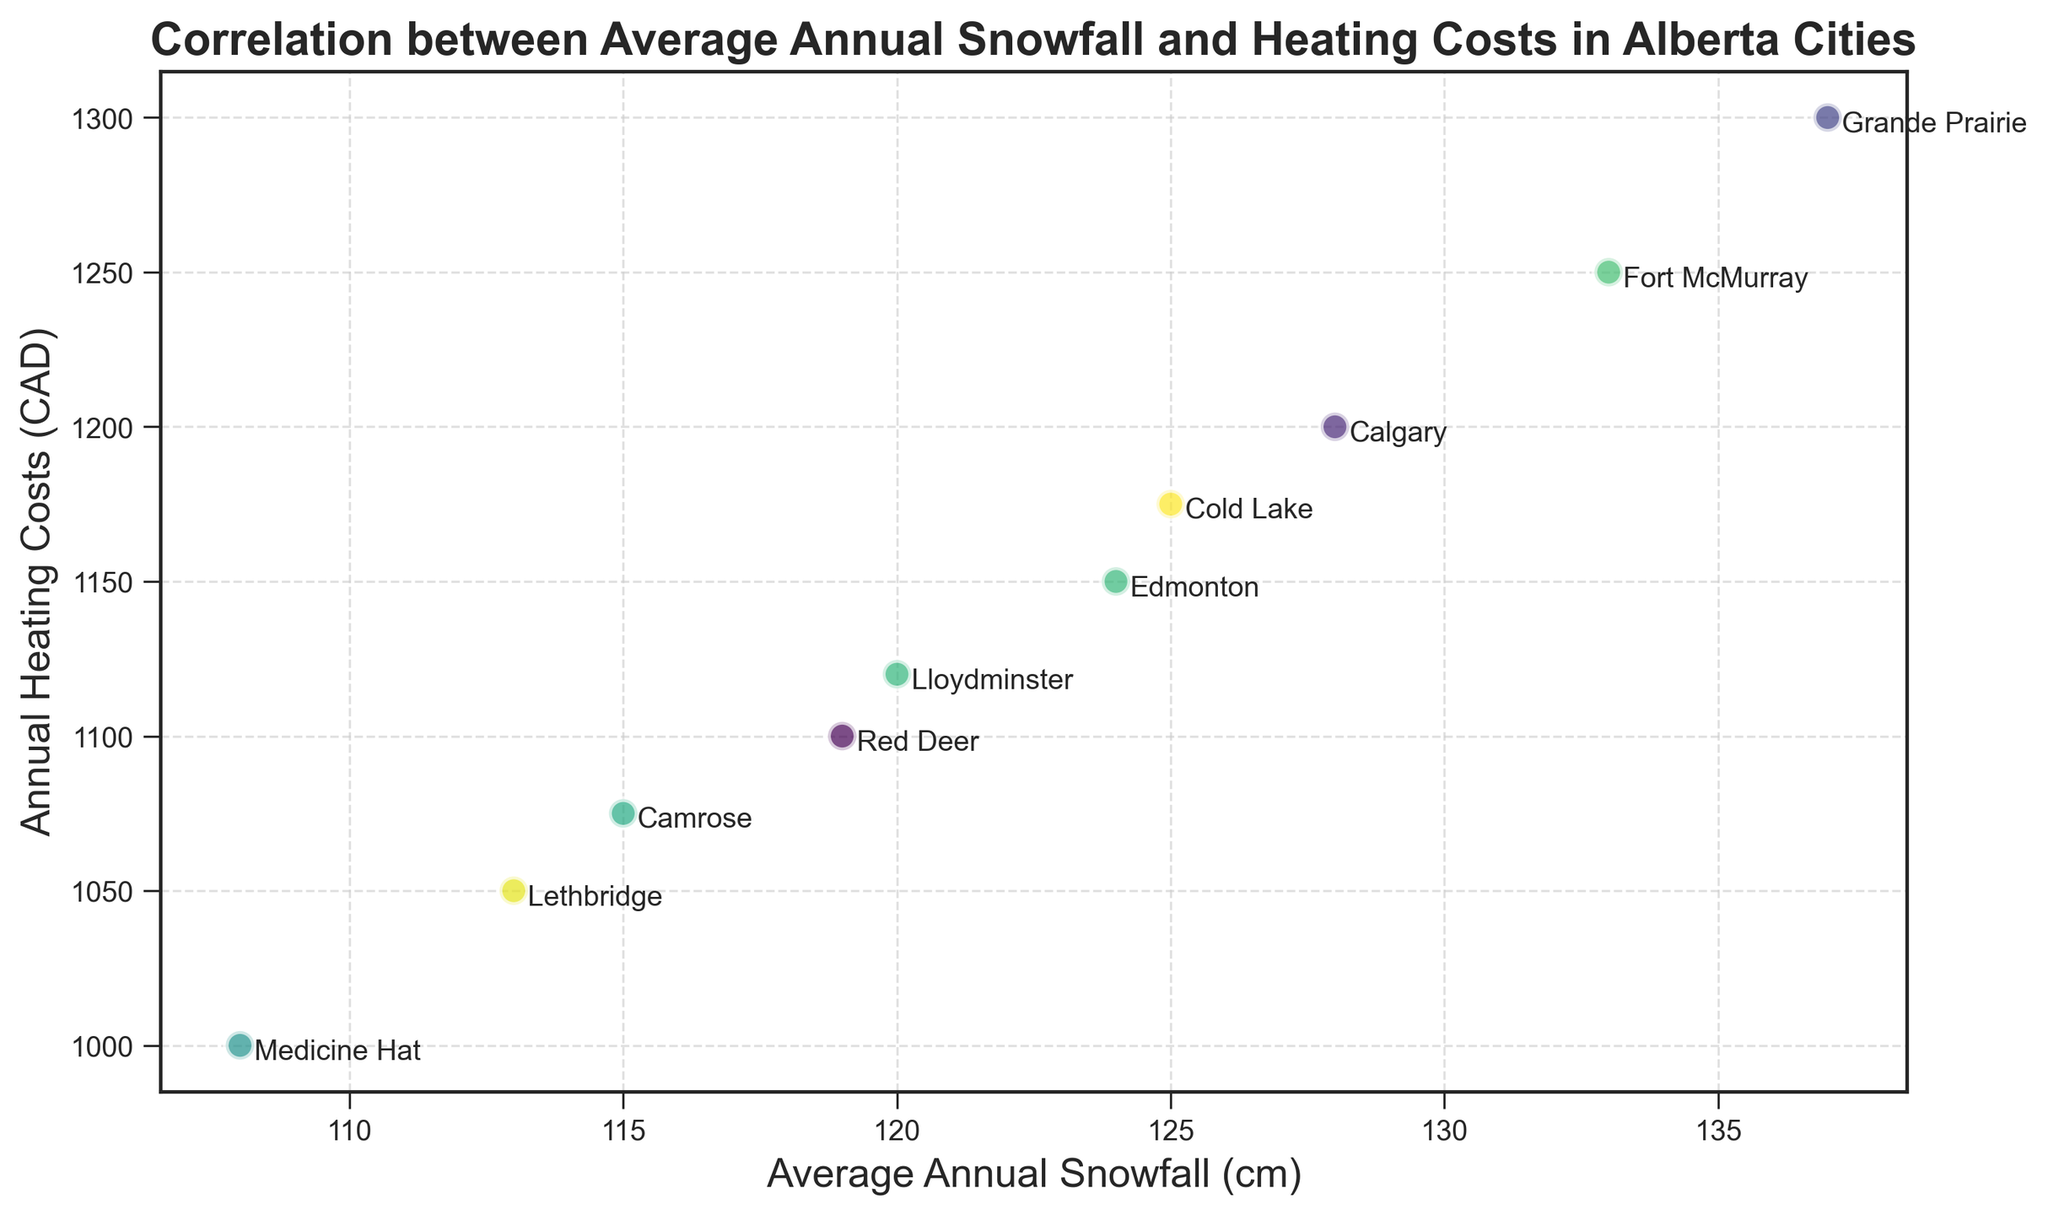Which city has the highest annual heating costs? Look at the y-axis, which represents the "Annual Heating Costs (CAD)". Identify the city with the highest y-value.
Answer: Grande Prairie Which city has the least average annual snowfall? Look at the x-axis, which represents the "Average Annual Snowfall (cm)". Identify the city with the lowest x-value.
Answer: Medicine Hat What is the difference in annual heating costs between Calgary and Edmonton? Find the y-values for both Calgary and Edmonton. Subtract the annual heating cost of Edmonton from that of Calgary: 1200 - 1150 = 50.
Answer: 50 CAD Is there a trend visible between average annual snowfall and heating costs? Observe the scatter of points. Notice if there's a pattern, such as if heating costs increase with snowfall or if there's no clear relationship.
Answer: Yes, heating costs generally increase with snowfall Which city has an average annual snowfall closest to 125 cm? Look along the x-axis for the value closest to 125 cm and determine the corresponding city.
Answer: Cold Lake How many cities have annual heating costs greater than 1100 CAD? Count the number of points that have their y-value (annual heating costs) above 1100 CAD.
Answer: 5 Which city is the most isolated in terms of heating costs and snowfall on the plot? Look for a point that stands out from the cluster of other points in both x-axis and y-axis values.
Answer: Grande Prairie What is the most common annual heating cost among the cities? Identify the y-values in the plot and see which one repeats the most.
Answer: 1150 CAD What is the average annual snowfall for the three cities with the lowest heating costs? Identify the cities with the three lowest y-values and calculate the average of their x-values. (Medicine Hat: 108, Lethbridge: 113, Camrose: 115. Average: (108+113+115)/3 = 112)
Answer: 112 cm What is the range of average annual snowfall among all cities? Find the minimum and maximum x-values (108 and 137, respectively) and subtract the minimum from the maximum: 137 - 108 = 29.
Answer: 29 cm 